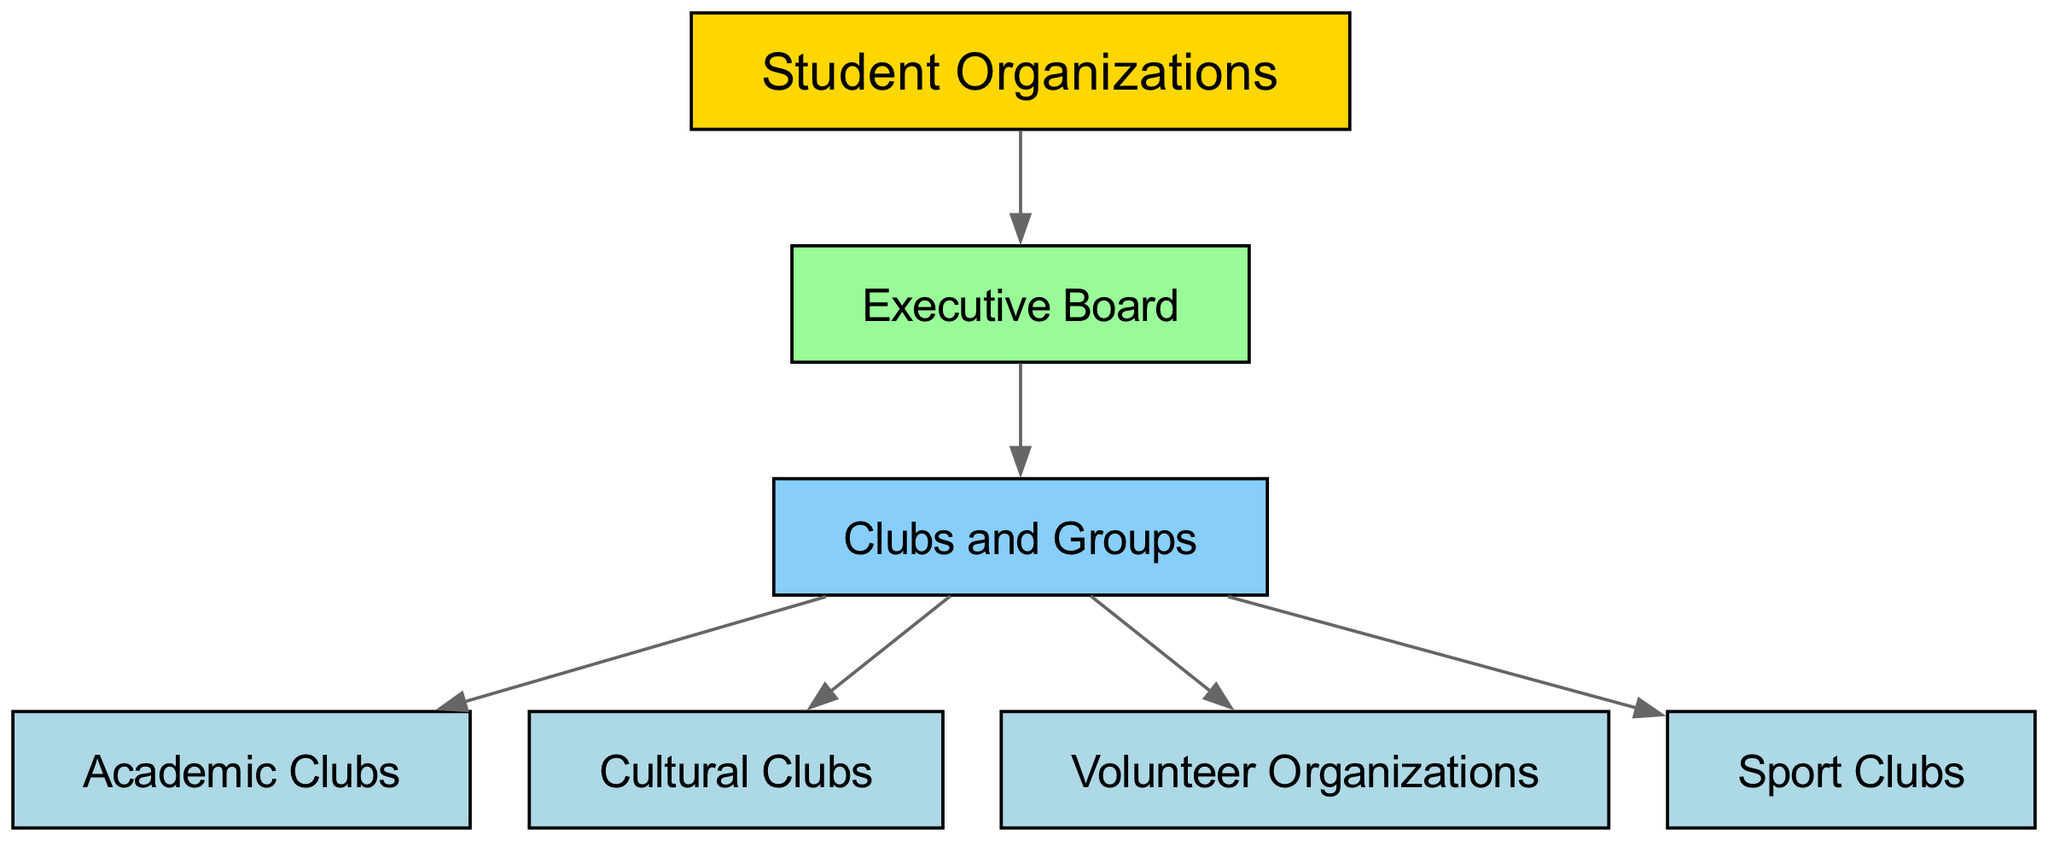What is the root node of the graph? The root node can be identified by looking for the node that does not have any incoming edges. In this case, "Student Organizations" is the only node that serves as the starting point of the directed graph, linking to other nodes without being linked from any other node.
Answer: Student Organizations How many nodes are there in total? To find the total number of nodes, we can count the unique nodes listed in the data structure. There are seven nodes: "Student Organizations", "Executive Board", "Clubs and Groups", "Academic Clubs", "Cultural Clubs", "Volunteer Organizations", and "Sport Clubs". Thus, the total is seven.
Answer: 7 Which node has the most outgoing edges? By examining the edges, we find that "Clubs and Groups" has outgoing edges to four nodes: "Academic Clubs", "Cultural Clubs", "Volunteer Organizations", and "Sport Clubs". No other node has as many outgoing connections.
Answer: Clubs and Groups What is the relationship between "Executive Board" and "Clubs and Groups"? The relationship can be determined by looking at the directed edge between the two nodes in the graph. The edge from "Executive Board" to "Clubs and Groups" indicates that the Executive Board oversees or is in charge of the Clubs and Groups.
Answer: Oversees How many edges connect "Clubs and Groups" to its subcategories? To find the number of edges connecting to the subcategories of "Clubs and Groups," we can count the edges that start from "Clubs and Groups." There are four outgoing edges to "Academic Clubs", "Cultural Clubs", "Volunteer Organizations", and "Sport Clubs".
Answer: 4 Which node does not link to any other nodes? To find a node that does not link to any others, we must identify nodes that do not serve as a source for outgoing edges. Nodes like "Academic Clubs", "Cultural Clubs", "Volunteer Organizations", and "Sport Clubs" do not have any outgoing edges, but are linked from "Clubs and Groups". All others have at least one connection.
Answer: Academic Clubs How many levels are there in the hierarchy? The hierarchy can be examined by identifying distinct levels from top to bottom. Starting at the top node "Student Organizations", we have the second level with "Executive Board," then the third level with "Clubs and Groups," and finally the fourth level with "Academic Clubs", "Cultural Clubs", "Volunteer Organizations", and "Sport Clubs". This yields a total of four levels.
Answer: 4 What is the bottom-level node? The bottom-level nodes are identified as those that do not have any outgoing edges. From the diagram, "Academic Clubs," "Cultural Clubs," "Volunteer Organizations," and "Sport Clubs" are located at the bottom of the hierarchy and do not connect to any other nodes.
Answer: Academic Clubs Which organization is directly connected to the "Executive Board"? The direct organization linked from "Executive Board" can be found by checking the outgoing edges. The only node that follows directly from "Executive Board" is "Clubs and Groups," indicating a direct connection.
Answer: Clubs and Groups 